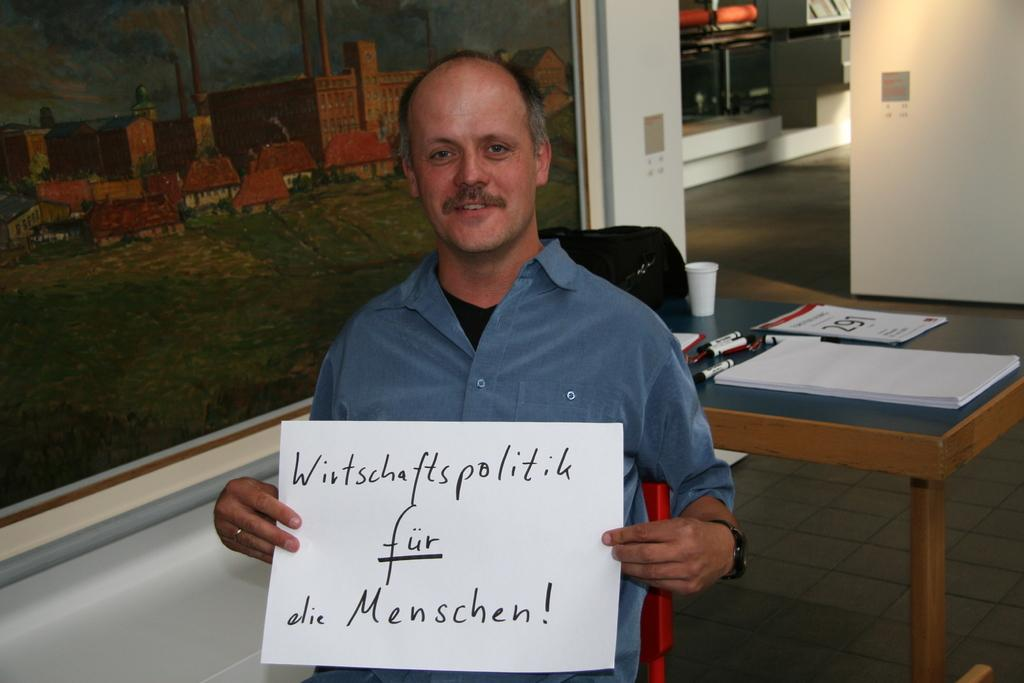What is the man in the image doing? The man is seated and holding a paper in his hands. What can be seen in the background of the image? There is a wall painting, papers, pens, and cups on a table in the background of the image. What might the man be using to write or draw on the paper? The pens on the table in the background of the image might be used for writing or drawing on the paper. How many dolls are present on the table in the image? There are no dolls present on the table in the image. 